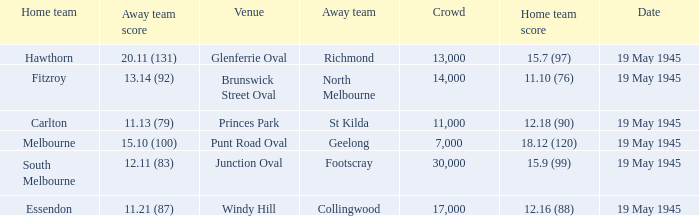On which date was Essendon the home team? 19 May 1945. 